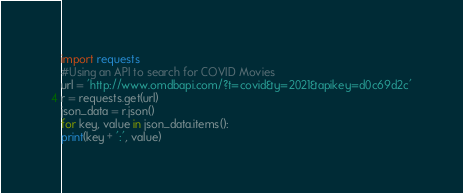<code> <loc_0><loc_0><loc_500><loc_500><_Python_>import requests
#Using an API to search for COVID Movies
url = 'http://www.omdbapi.com/?t=covid&y=2021&apikey=d0c69d2c'
r = requests.get(url)
json_data = r.json()
for key, value in json_data.items():
print(key + ':', value)</code> 